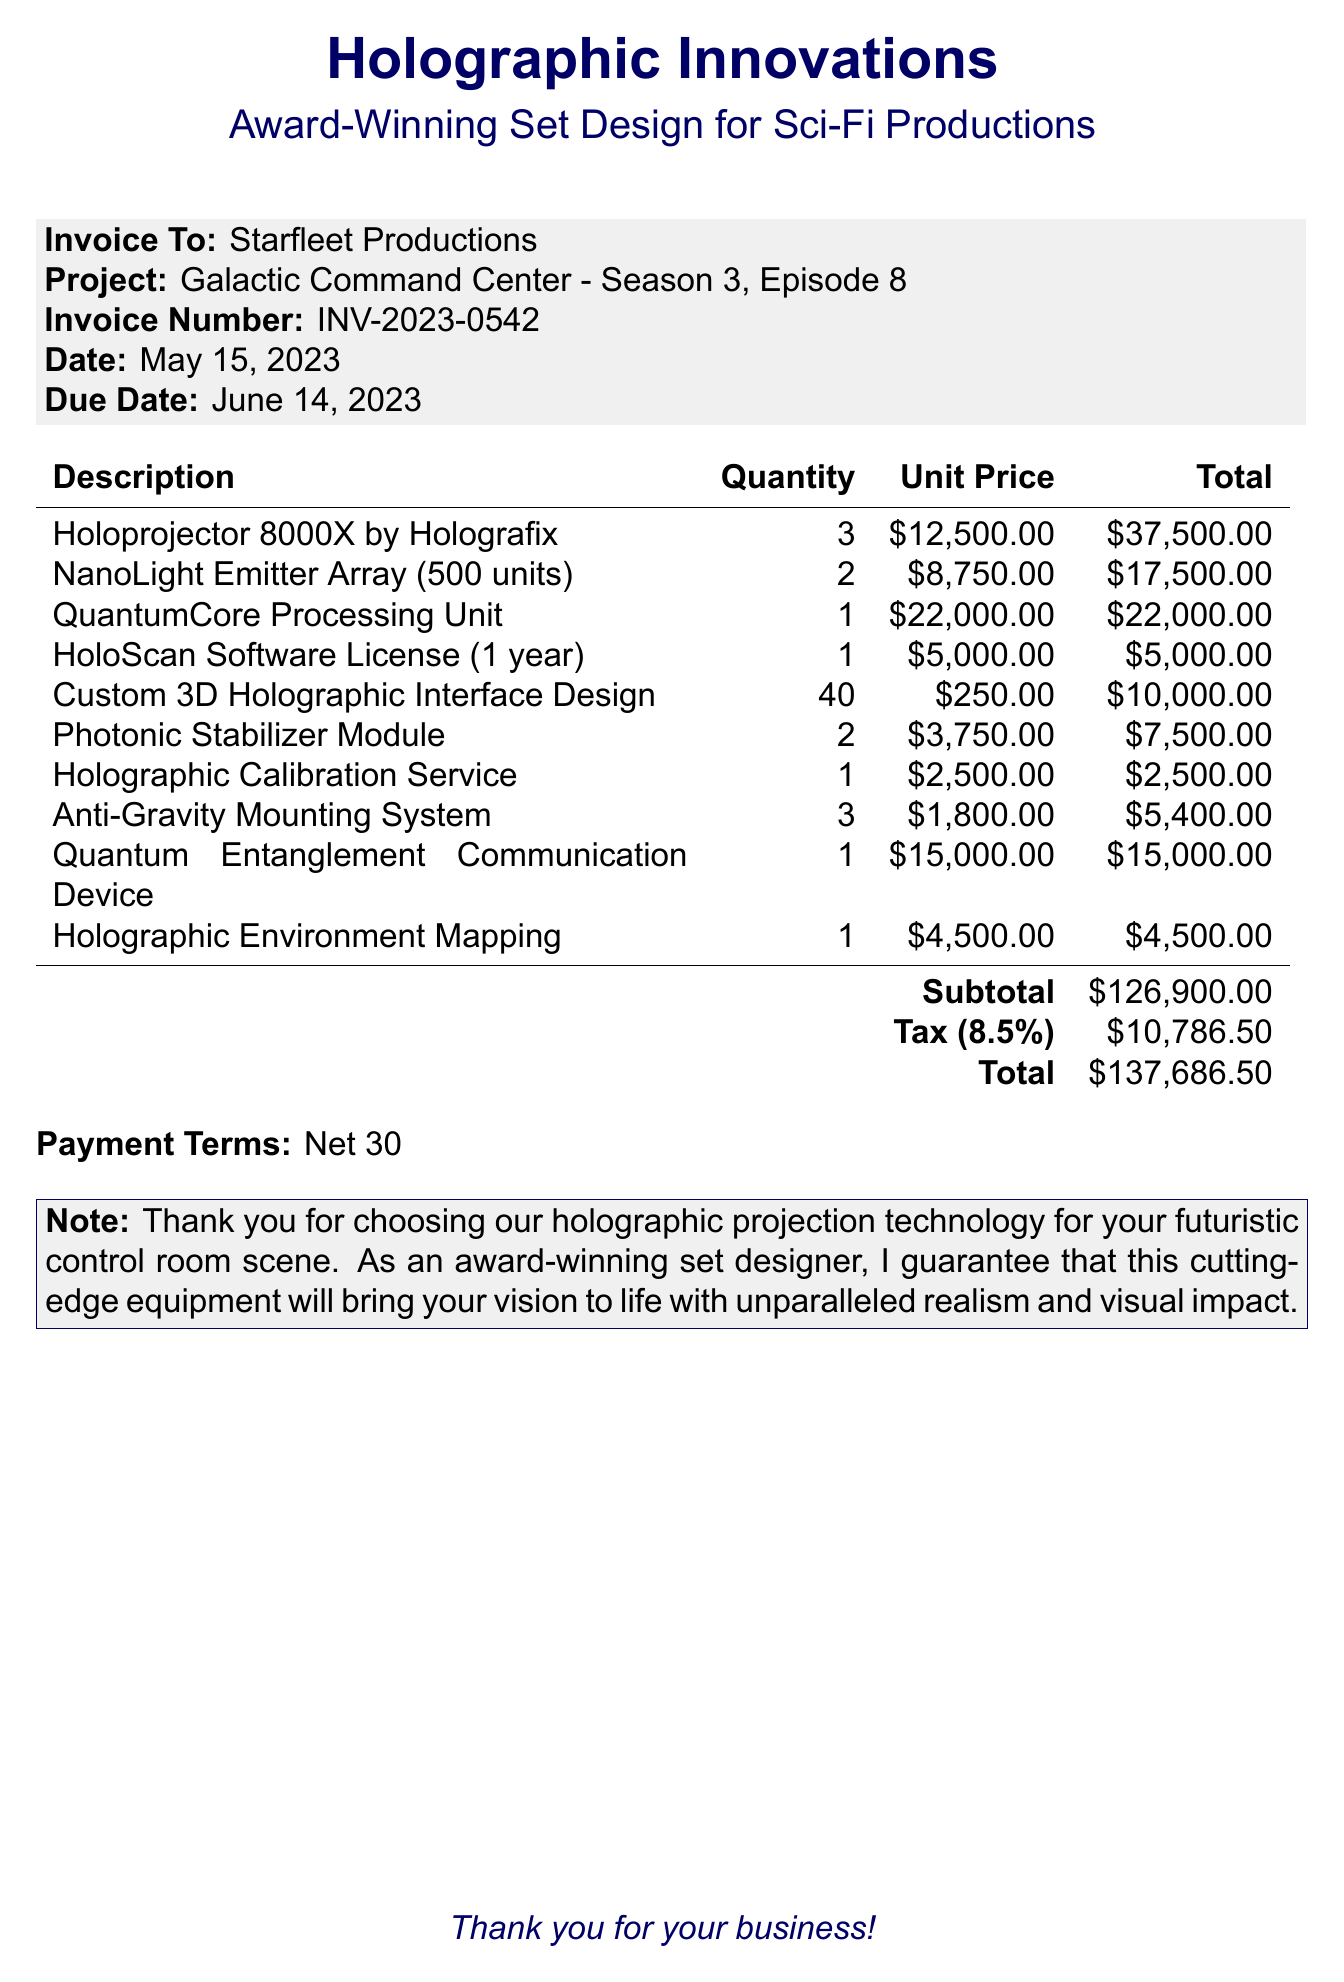What is the invoice number? The invoice number is found prominently at the top of the document.
Answer: INV-2023-0542 What is the due date? The due date is specified in the document under the invoice details.
Answer: June 14, 2023 Who is the client? The client's name is indicated in the "Invoice To" section of the document.
Answer: Starfleet Productions What item has the highest unit price? The item with the highest unit price is identified in the itemized list of the invoice.
Answer: QuantumCore Processing Unit What is the subtotal amount? The subtotal is calculated before tax and is specified towards the end of the invoice.
Answer: $126,900.00 What is the tax rate applied? The tax rate is noted in the invoice below the subtotal.
Answer: 8.5% How many Holoprojector 8000X units were ordered? The quantity of Holoprojector 8000X is listed in the relevant item entry.
Answer: 3 What is the total amount due? The total amount is the final figure at the end of the invoice.
Answer: $137,686.50 What special note is provided at the bottom of the invoice? The note expresses gratitude and highlights the quality of the service provided.
Answer: Thank you for choosing our holographic projection technology for your futuristic control room scene 